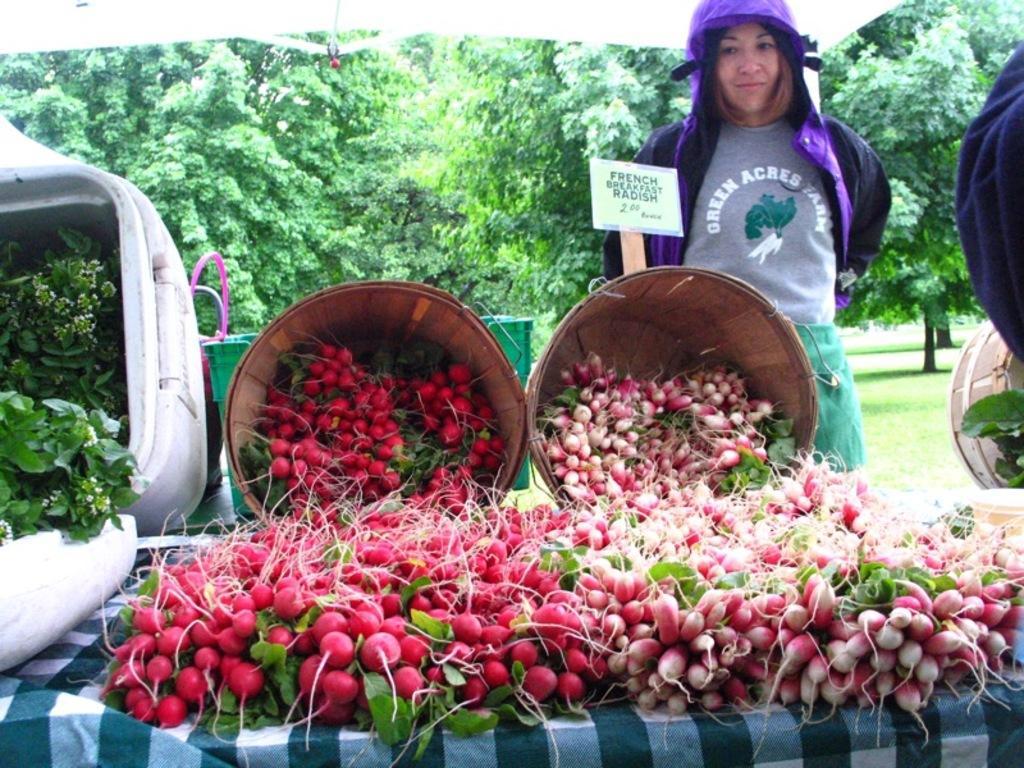Please provide a concise description of this image. In the image there are a lot of radishes in the foreground, behind them there is a woman and she is standing behind a basket and in the background there are a lot of trees. 